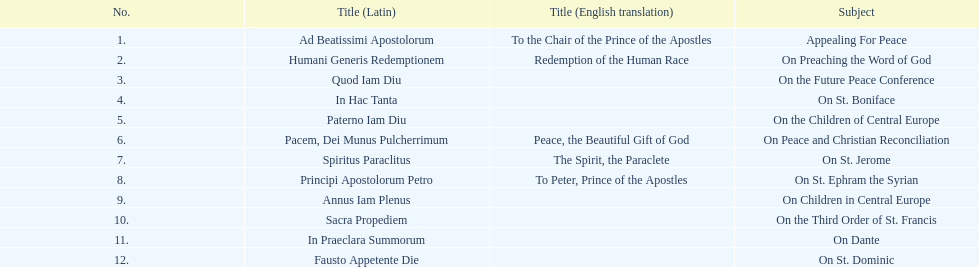Which title comes after sacra propediem in the sequence? In Praeclara Summorum. 